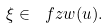Convert formula to latex. <formula><loc_0><loc_0><loc_500><loc_500>\xi \in \ f z w ( u ) .</formula> 